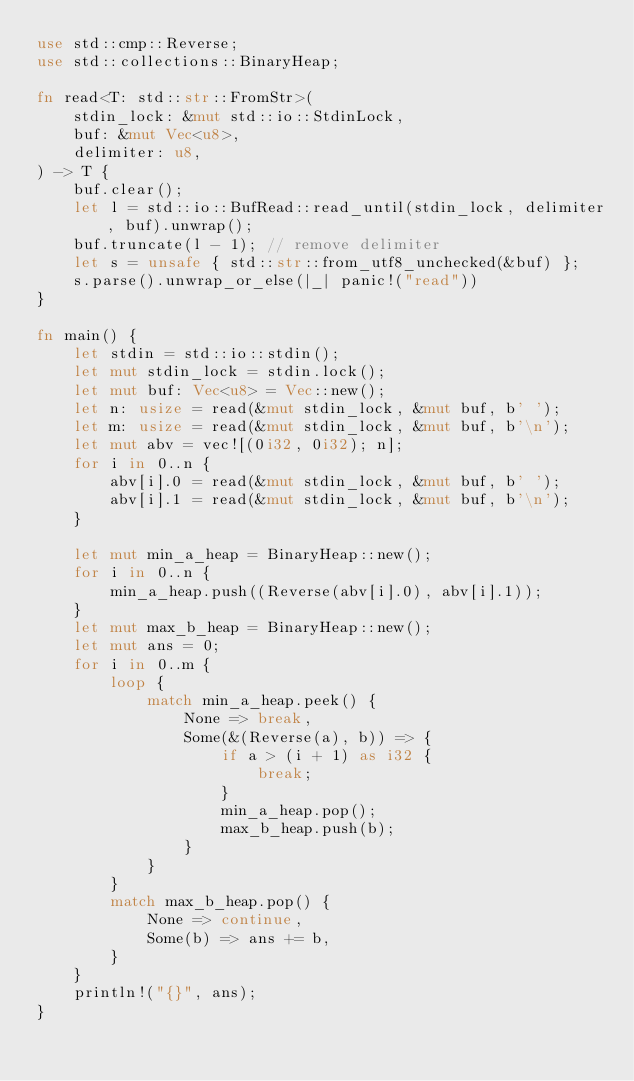<code> <loc_0><loc_0><loc_500><loc_500><_Rust_>use std::cmp::Reverse;
use std::collections::BinaryHeap;

fn read<T: std::str::FromStr>(
    stdin_lock: &mut std::io::StdinLock,
    buf: &mut Vec<u8>,
    delimiter: u8,
) -> T {
    buf.clear();
    let l = std::io::BufRead::read_until(stdin_lock, delimiter, buf).unwrap();
    buf.truncate(l - 1); // remove delimiter
    let s = unsafe { std::str::from_utf8_unchecked(&buf) };
    s.parse().unwrap_or_else(|_| panic!("read"))
}

fn main() {
    let stdin = std::io::stdin();
    let mut stdin_lock = stdin.lock();
    let mut buf: Vec<u8> = Vec::new();
    let n: usize = read(&mut stdin_lock, &mut buf, b' ');
    let m: usize = read(&mut stdin_lock, &mut buf, b'\n');
    let mut abv = vec![(0i32, 0i32); n];
    for i in 0..n {
        abv[i].0 = read(&mut stdin_lock, &mut buf, b' ');
        abv[i].1 = read(&mut stdin_lock, &mut buf, b'\n');
    }

    let mut min_a_heap = BinaryHeap::new();
    for i in 0..n {
        min_a_heap.push((Reverse(abv[i].0), abv[i].1));
    }
    let mut max_b_heap = BinaryHeap::new();
    let mut ans = 0;
    for i in 0..m {
        loop {
            match min_a_heap.peek() {
                None => break,
                Some(&(Reverse(a), b)) => {
                    if a > (i + 1) as i32 {
                        break;
                    }
                    min_a_heap.pop();
                    max_b_heap.push(b);
                }
            }
        }
        match max_b_heap.pop() {
            None => continue,
            Some(b) => ans += b,
        }
    }
    println!("{}", ans);
}
</code> 